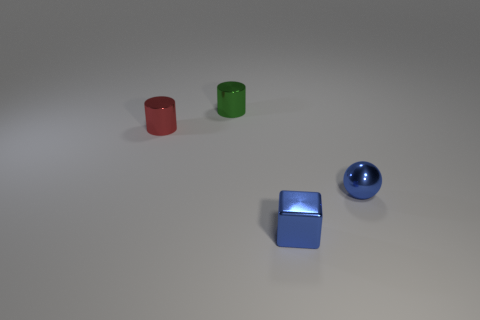What is the size of the ball that is the same color as the block?
Offer a very short reply. Small. There is a small shiny cylinder behind the small red thing; what number of metal cylinders are to the left of it?
Ensure brevity in your answer.  1. How many other objects are the same size as the blue shiny sphere?
Your answer should be compact. 3. Does the small metallic sphere have the same color as the block?
Provide a succinct answer. Yes. There is a blue metal object that is in front of the tiny sphere; is it the same shape as the green metallic thing?
Make the answer very short. No. What number of small objects are on the right side of the green shiny object and to the left of the tiny metal block?
Give a very brief answer. 0. What material is the small green cylinder?
Your answer should be very brief. Metal. Is there any other thing that has the same color as the tiny metal cube?
Give a very brief answer. Yes. There is a green metal thing that is behind the tiny metal thing in front of the sphere; how many tiny shiny things are to the left of it?
Offer a terse response. 1. What number of tiny balls are there?
Make the answer very short. 1. 